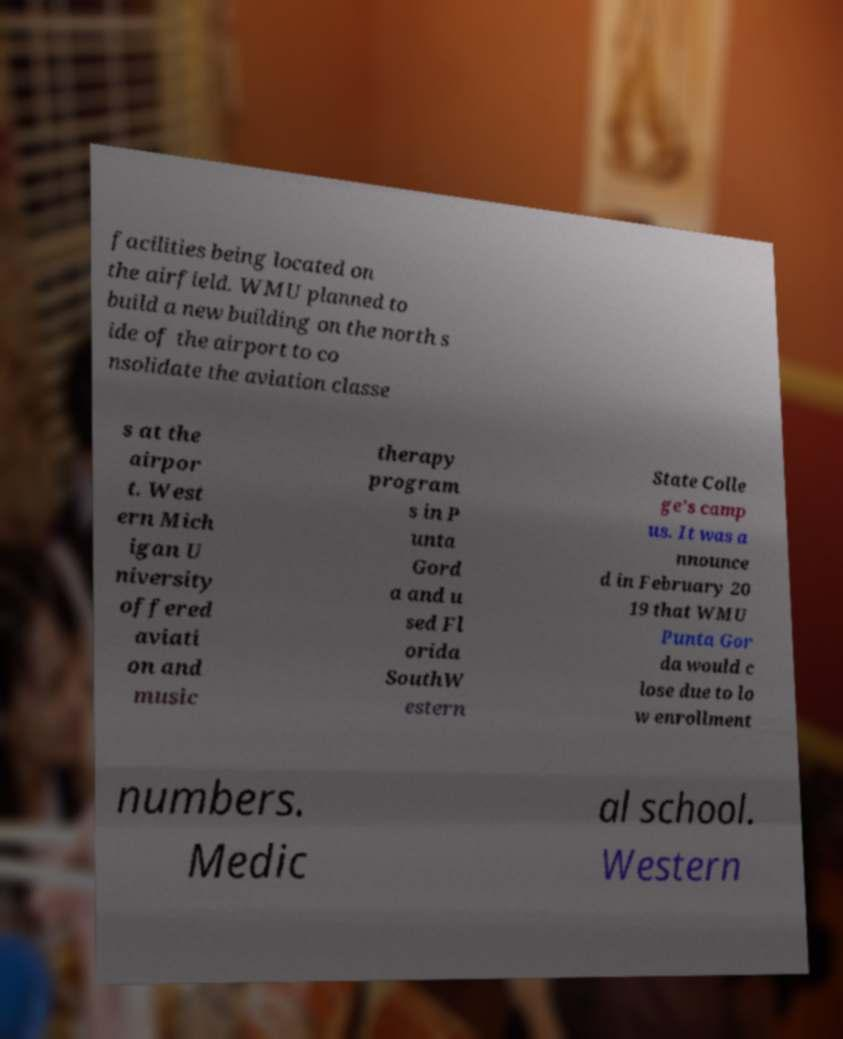Could you assist in decoding the text presented in this image and type it out clearly? facilities being located on the airfield. WMU planned to build a new building on the north s ide of the airport to co nsolidate the aviation classe s at the airpor t. West ern Mich igan U niversity offered aviati on and music therapy program s in P unta Gord a and u sed Fl orida SouthW estern State Colle ge’s camp us. It was a nnounce d in February 20 19 that WMU Punta Gor da would c lose due to lo w enrollment numbers. Medic al school. Western 